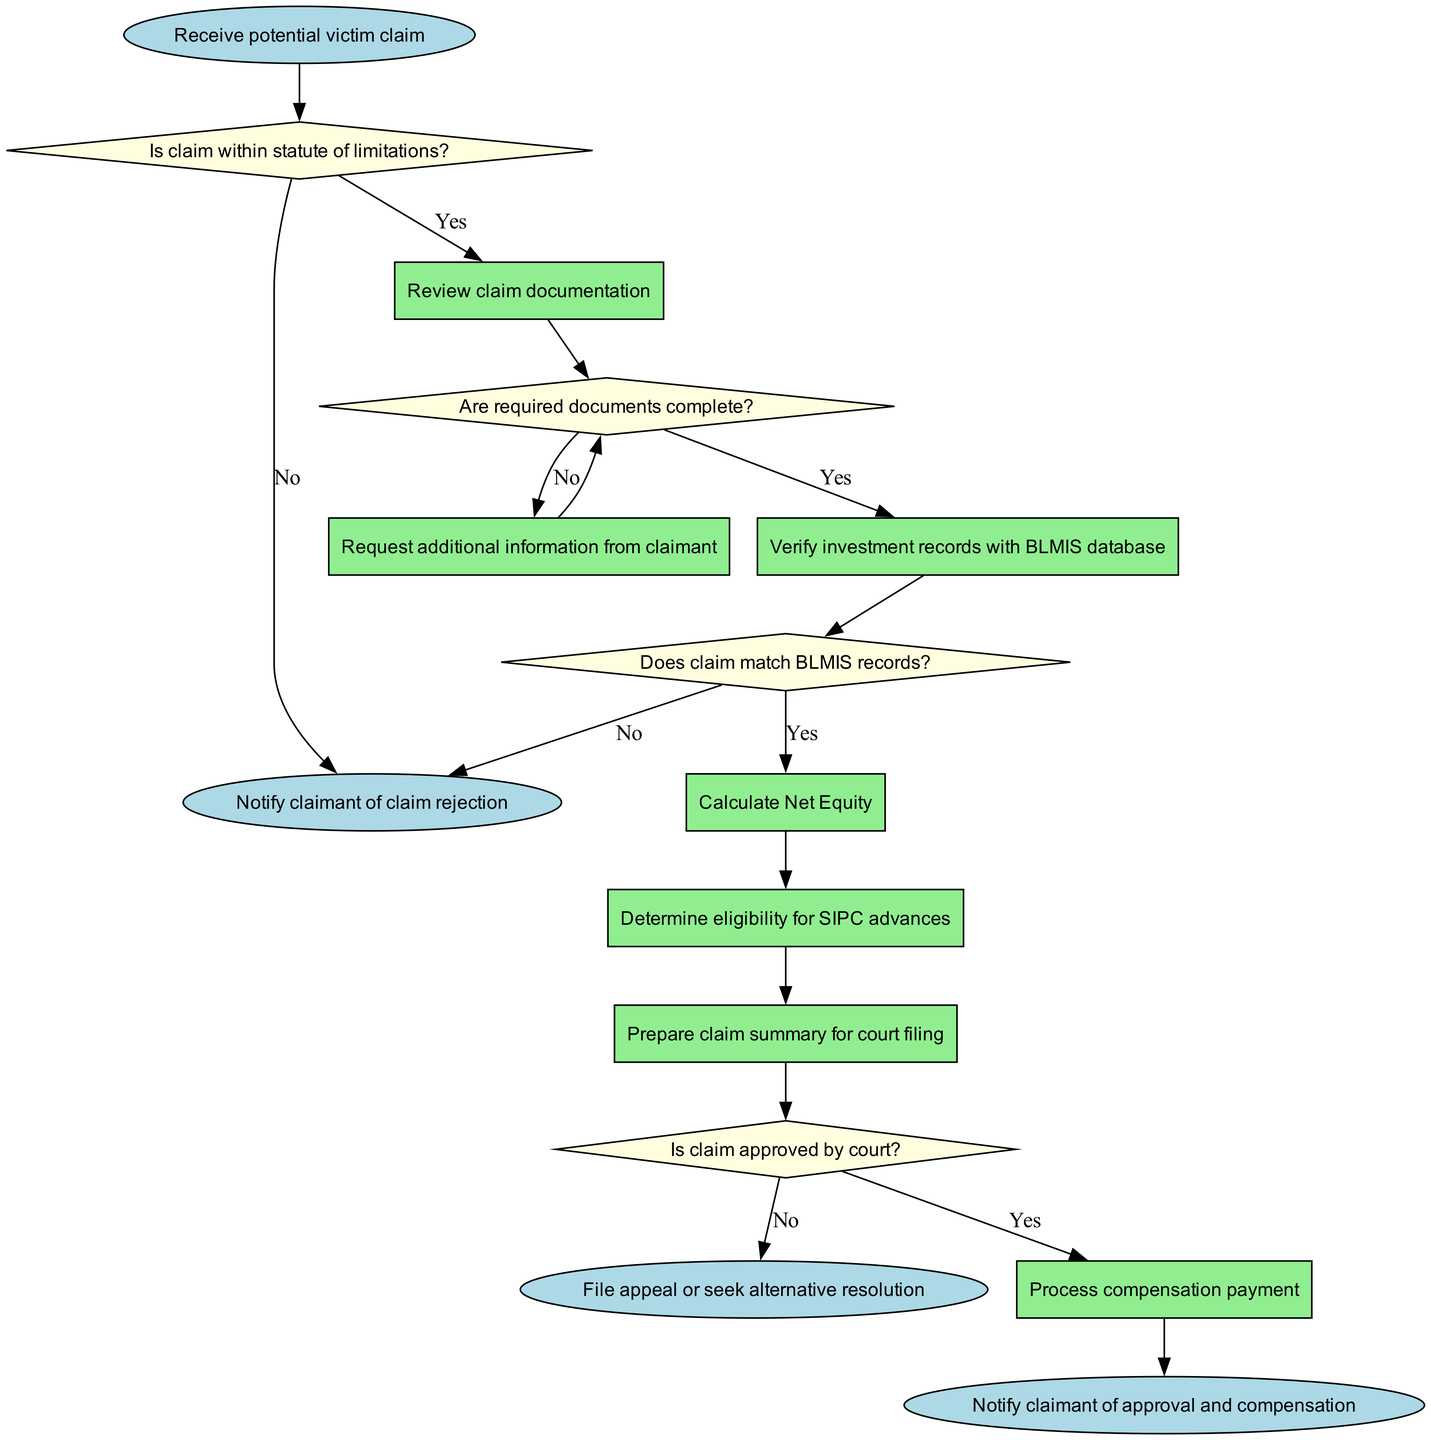What is the starting point of the workflow? The starting point is indicated by the "start" node, which states "Receive potential victim claim". This node is the first action in the workflow.
Answer: Receive potential victim claim What decision must be made after receiving a claim? The first decision node in the workflow is "Is claim within statute of limitations?", which mandates that a determination must be made regarding the timeliness of the claim.
Answer: Is claim within statute of limitations? How many process steps are there in total in the workflow? By counting the nodes labeled as "process" in the diagram, we find that there are a total of six process nodes.
Answer: 6 What happens if the claim does not match BLMIS records? According to the flowchart, if the claim does not match BLMIS records (as indicated in the "decision_3" node), the workflow proceeds to the "end_2" node, which states "Notify claimant of claim rejection".
Answer: Notify claimant of claim rejection What is the last process step before a court approval decision is made? The last process step before the decision on court approval is "Prepare claim summary for court filing", as indicated in the diagram leading up to "decision_4".
Answer: Prepare claim summary for court filing If the court approves the claim, what is the next action taken? If the claim is approved as shown by the arrow emanating from "decision_4" labeled 'Yes', the next action taken is "Process compensation payment".
Answer: Process compensation payment How many decision nodes are present in the workflow? By examining each node and counting those labeled as "decision", we find that there are four decision nodes in the workflow.
Answer: 4 What would trigger a notification of claim rejection? A notification of claim rejection is triggered after the "decision_1" node if the answer is 'No', or if the claim does not match the records as determined in "decision_3", leading to "end_2".
Answer: No, claim does not match records What is the first process step after confirming the claim is within the statute of limitations? The first process step after confirming the claim is within the statute of limitations is "Review claim documentation", following from the "decision_1" node.
Answer: Review claim documentation 